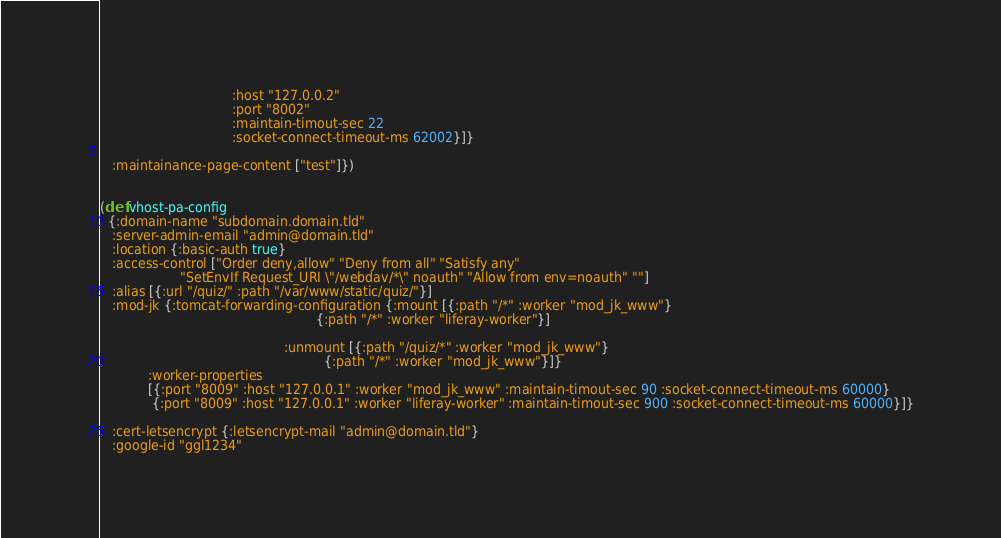<code> <loc_0><loc_0><loc_500><loc_500><_Clojure_>                                 :host "127.0.0.2"
                                 :port "8002"
                                 :maintain-timout-sec 22
                                 :socket-connect-timeout-ms 62002}]}

   :maintainance-page-content ["test"]})


(def vhost-pa-config
  {:domain-name "subdomain.domain.tld"
   :server-admin-email "admin@domain.tld"
   :location {:basic-auth true}
   :access-control ["Order deny,allow" "Deny from all" "Satisfy any"
                    "SetEnvIf Request_URI \"/webdav/*\" noauth" "Allow from env=noauth" ""]
   :alias [{:url "/quiz/" :path "/var/www/static/quiz/"}]
   :mod-jk {:tomcat-forwarding-configuration {:mount [{:path "/*" :worker "mod_jk_www"}
                                                      {:path "/*" :worker "liferay-worker"}]

                                              :unmount [{:path "/quiz/*" :worker "mod_jk_www"}
                                                        {:path "/*" :worker "mod_jk_www"}]}
            :worker-properties
            [{:port "8009" :host "127.0.0.1" :worker "mod_jk_www" :maintain-timout-sec 90 :socket-connect-timeout-ms 60000}
             {:port "8009" :host "127.0.0.1" :worker "liferay-worker" :maintain-timout-sec 900 :socket-connect-timeout-ms 60000}]}

   :cert-letsencrypt {:letsencrypt-mail "admin@domain.tld"}
   :google-id "ggl1234"</code> 